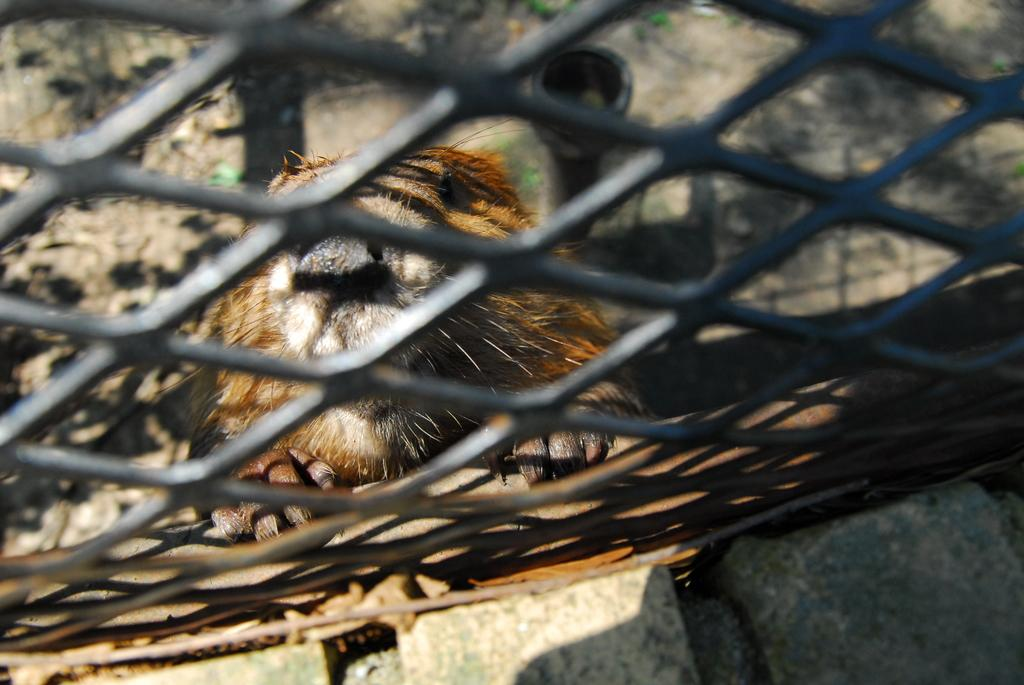What type of objects can be seen in the image? There are stones and a grille in the image. Is there any living creature present in the image? Yes, there is an animal in the image. Can you describe the unspecified object in the image? Unfortunately, the description of the unspecified object is not provided in the facts. What can be seen through the grille in the image? The ground is visible through the grille in the image. How many clams are present in the image? There are no clams present in the image. What fact can be learned about the animal in the image? The facts provided do not include any information about the animal, so we cannot determine any specific facts about it. 